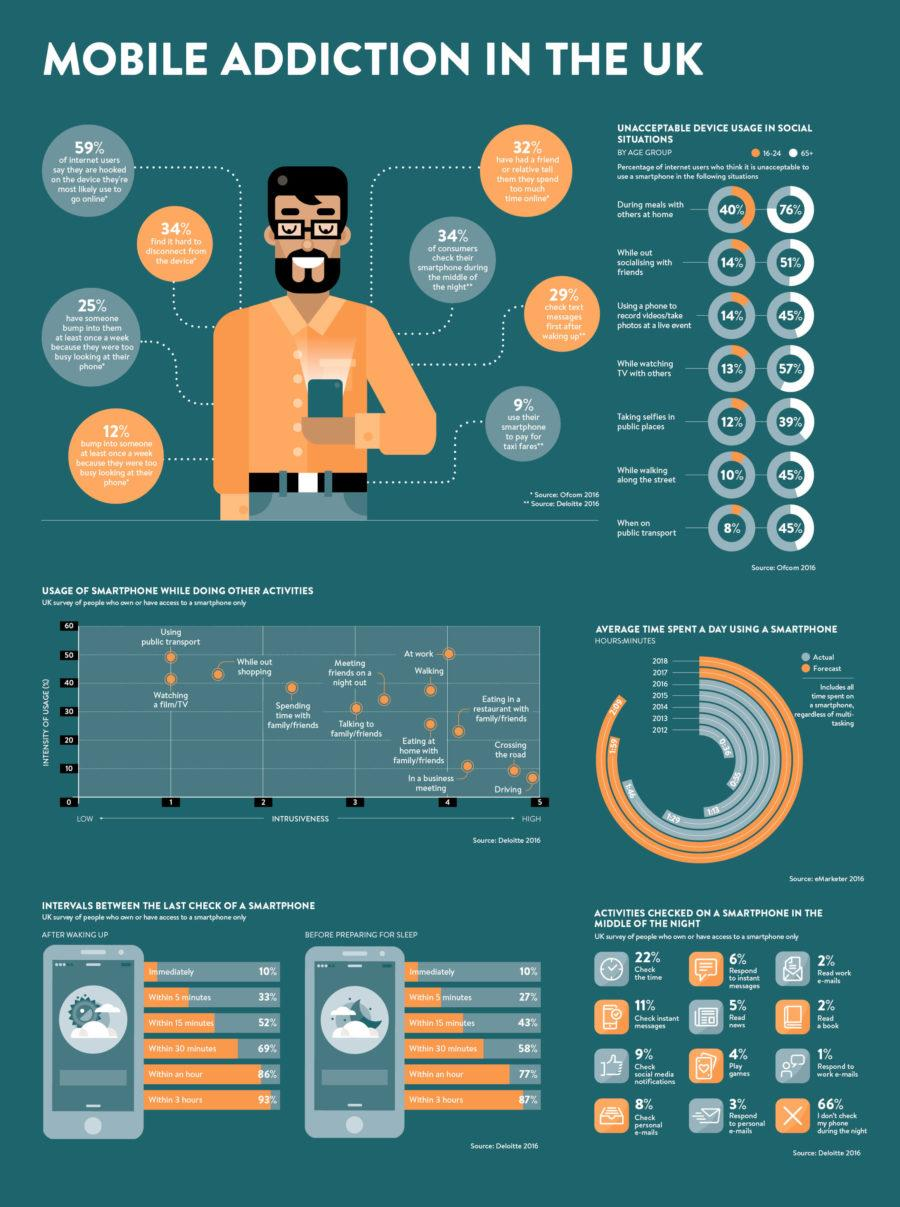Point out several critical features in this image. Public transport usage and watching a film/TV are the least intrusive activities for smartphone usage, as they allow individuals to multitask and stay connected without disrupting their surroundings or personal interactions. According to a recent survey, only 14% of young adults believe that they should not use the internet while socializing and at live events. According to the data, 88% of young adults believe it is acceptable to take selfies in public places. According to a survey, 33% of people do not check their mobile phone one hour before going to bed. A significant percentage of users do not use their phone at night, with 66% being the case. 